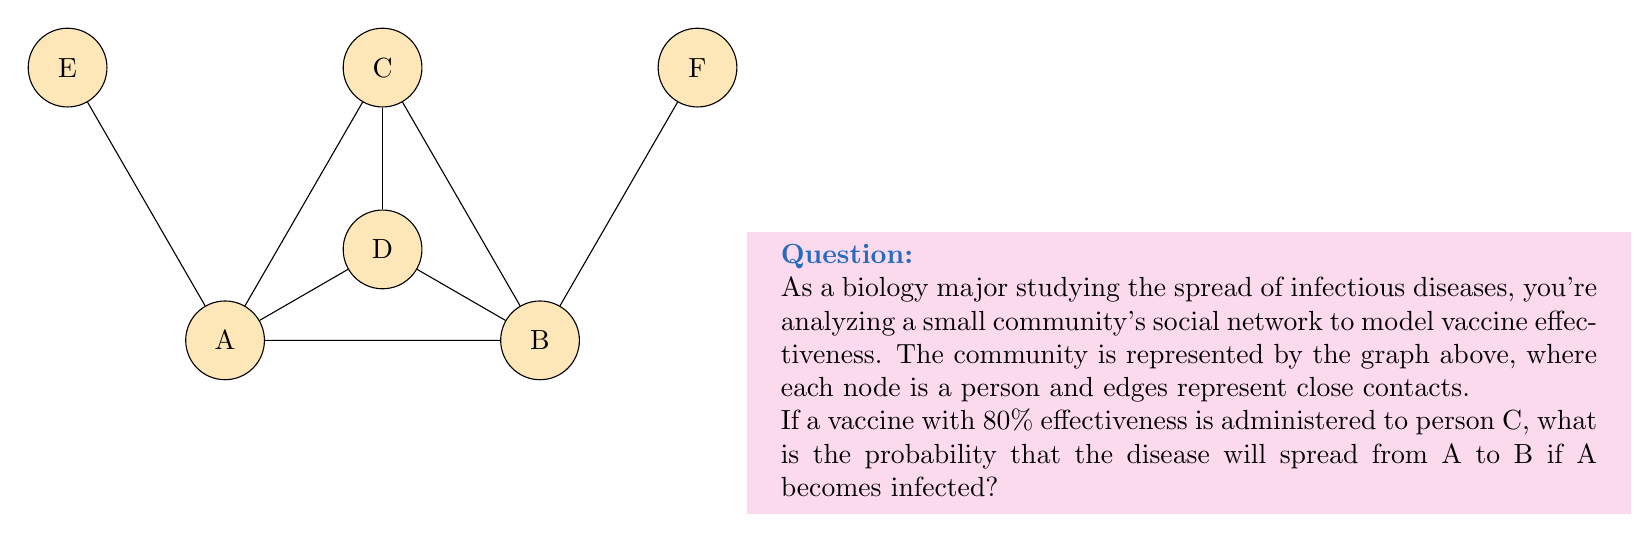Show me your answer to this math problem. Let's approach this step-by-step:

1) First, we need to identify all possible paths from A to B:
   - A → B (direct)
   - A → C → B
   - A → C → D → B
   - A → D → B

2) The vaccine on C affects only the paths that go through C. The probability of the disease spreading through C is reduced by 80%, so there's a 20% chance it can pass through C.

3) Let's calculate the probability of the disease not spreading for each path:
   - A → B: $P(\text{not A→B}) = 0$ (we assume 100% transmission for direct contacts)
   - A → C → B: $P(\text{not A→C→B}) = 1 - 0.2 \times 1 = 0.8$
   - A → C → D → B: $P(\text{not A→C→D→B}) = 1 - 0.2 \times 1 \times 1 = 0.8$
   - A → D → B: $P(\text{not A→D→B}) = 0$ (100% transmission)

4) The probability that the disease doesn't spread from A to B is the product of all these probabilities:

   $$P(\text{no spread}) = 0 \times 0.8 \times 0.8 \times 0 = 0$$

5) Therefore, the probability that the disease will spread from A to B is:

   $$P(\text{spread}) = 1 - P(\text{no spread}) = 1 - 0 = 1$$
Answer: 1 